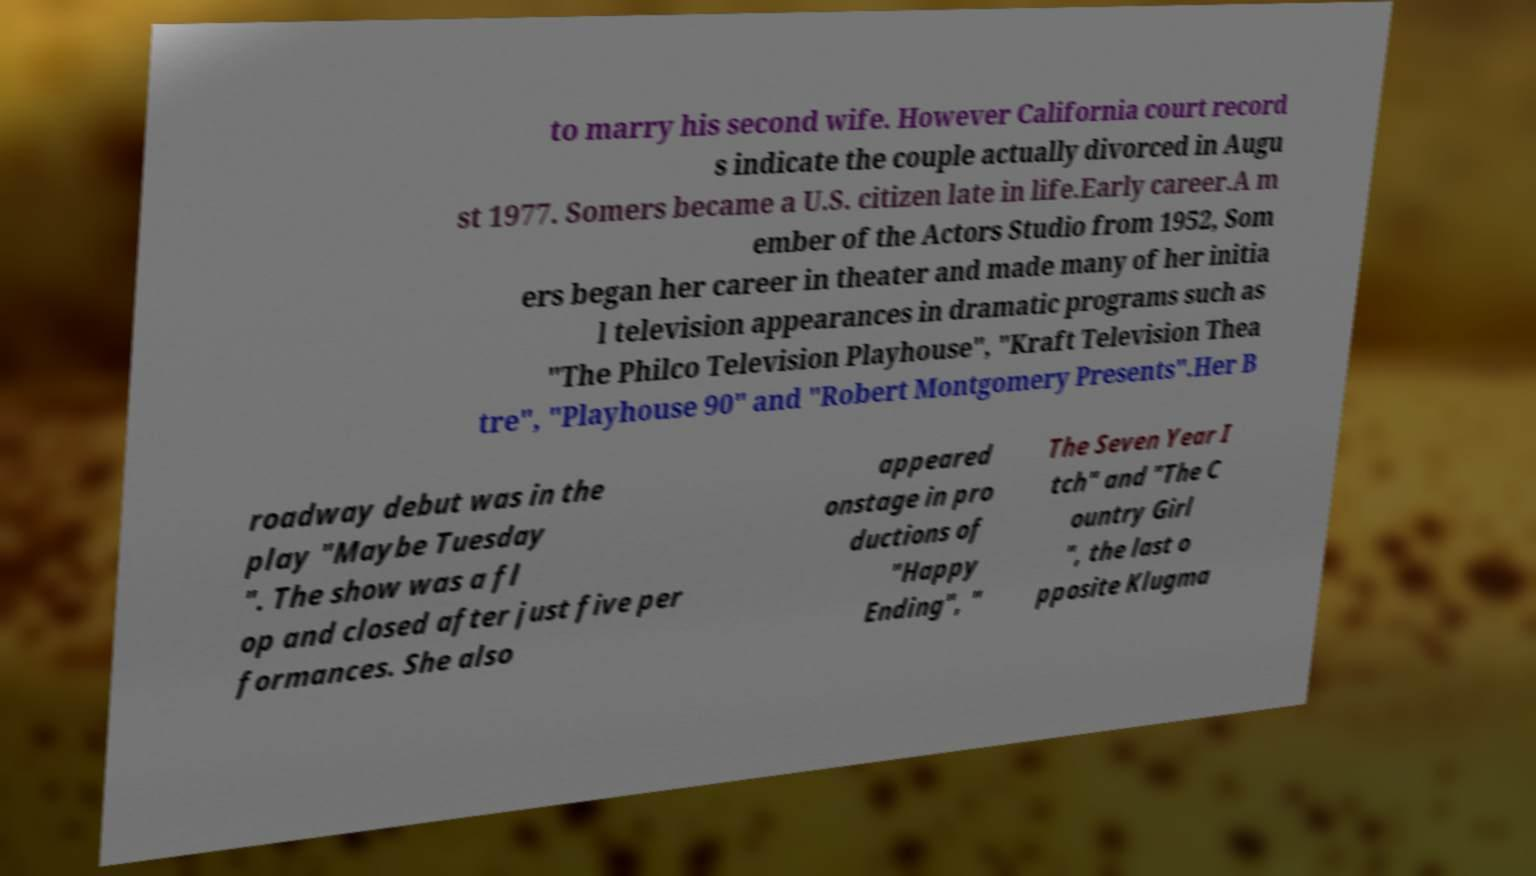Could you extract and type out the text from this image? to marry his second wife. However California court record s indicate the couple actually divorced in Augu st 1977. Somers became a U.S. citizen late in life.Early career.A m ember of the Actors Studio from 1952, Som ers began her career in theater and made many of her initia l television appearances in dramatic programs such as "The Philco Television Playhouse", "Kraft Television Thea tre", "Playhouse 90" and "Robert Montgomery Presents".Her B roadway debut was in the play "Maybe Tuesday ". The show was a fl op and closed after just five per formances. She also appeared onstage in pro ductions of "Happy Ending", " The Seven Year I tch" and "The C ountry Girl ", the last o pposite Klugma 